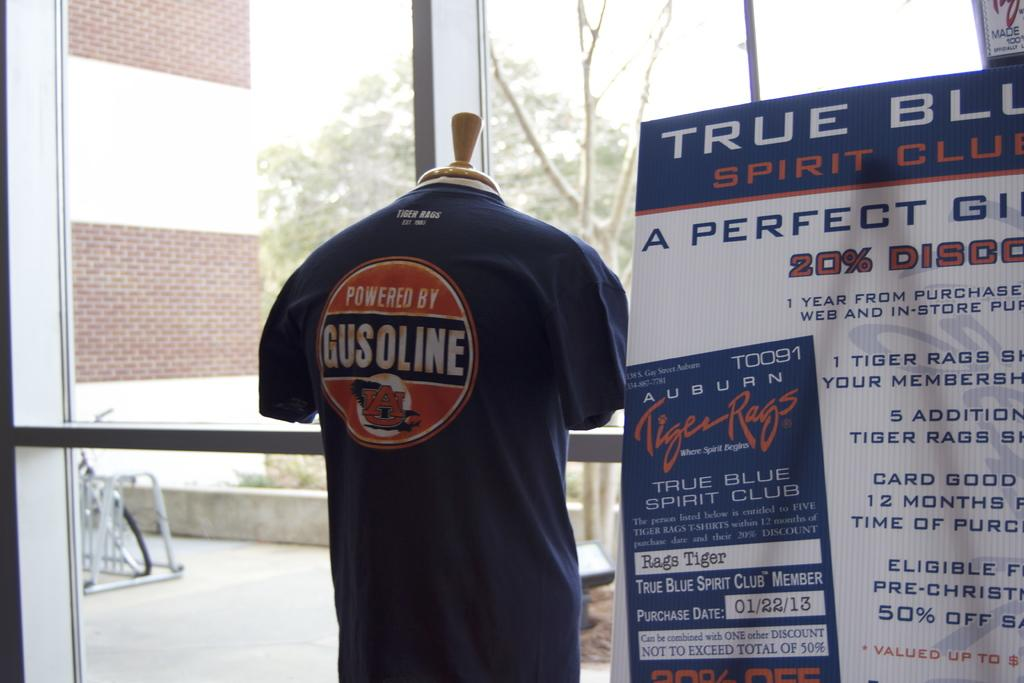<image>
Describe the image concisely. a shirt that has the word gusoline on it in a shop 